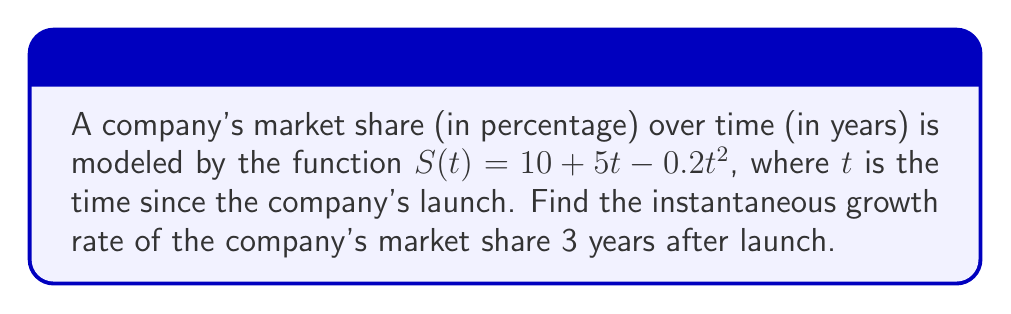Show me your answer to this math problem. To find the instantaneous growth rate of market share at a specific point in time, we need to calculate the derivative of the given function and evaluate it at the specified time.

Step 1: Identify the function
$S(t) = 10 + 5t - 0.2t^2$

Step 2: Calculate the derivative
$$\frac{dS}{dt} = 5 - 0.4t$$

Step 3: Evaluate the derivative at t = 3 years
$$\frac{dS}{dt}\bigg|_{t=3} = 5 - 0.4(3) = 5 - 1.2 = 3.8$$

The instantaneous growth rate is the value of the derivative at the given point. In this case, it represents the rate of change of market share with respect to time, measured in percentage points per year.
Answer: 3.8 percentage points per year 